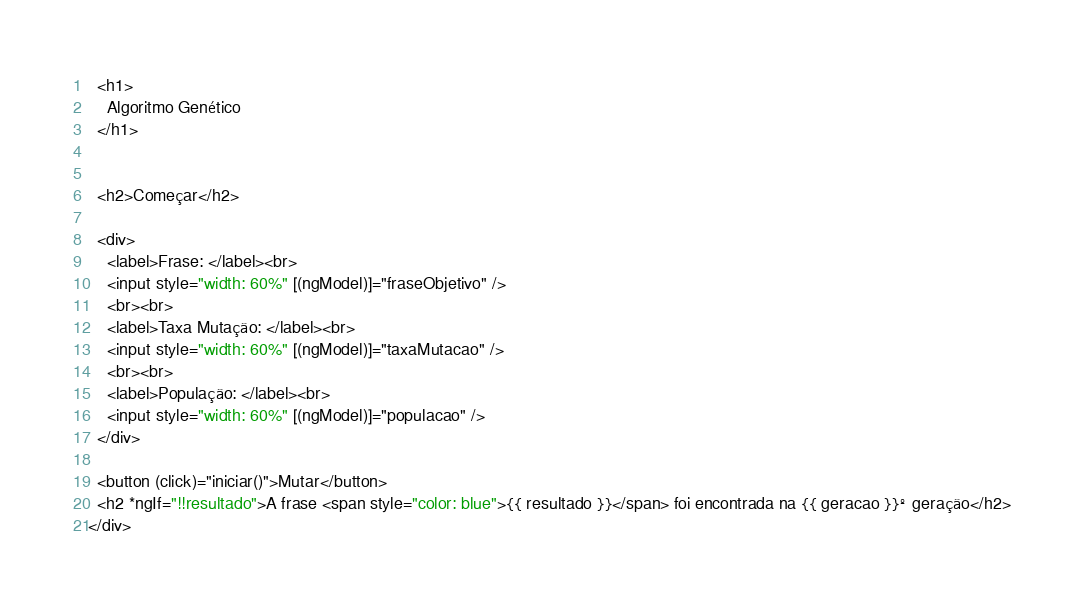Convert code to text. <code><loc_0><loc_0><loc_500><loc_500><_HTML_>  <h1>
    Algoritmo Genético
  </h1>


  <h2>Começar</h2>

  <div>
    <label>Frase: </label><br>
    <input style="width: 60%" [(ngModel)]="fraseObjetivo" />
    <br><br>
    <label>Taxa Mutação: </label><br>
    <input style="width: 60%" [(ngModel)]="taxaMutacao" />
    <br><br>
    <label>População: </label><br>
    <input style="width: 60%" [(ngModel)]="populacao" />
  </div>

  <button (click)="iniciar()">Mutar</button>
  <h2 *ngIf="!!resultado">A frase <span style="color: blue">{{ resultado }}</span> foi encontrada na {{ geracao }}º geração</h2>
</div>



</code> 